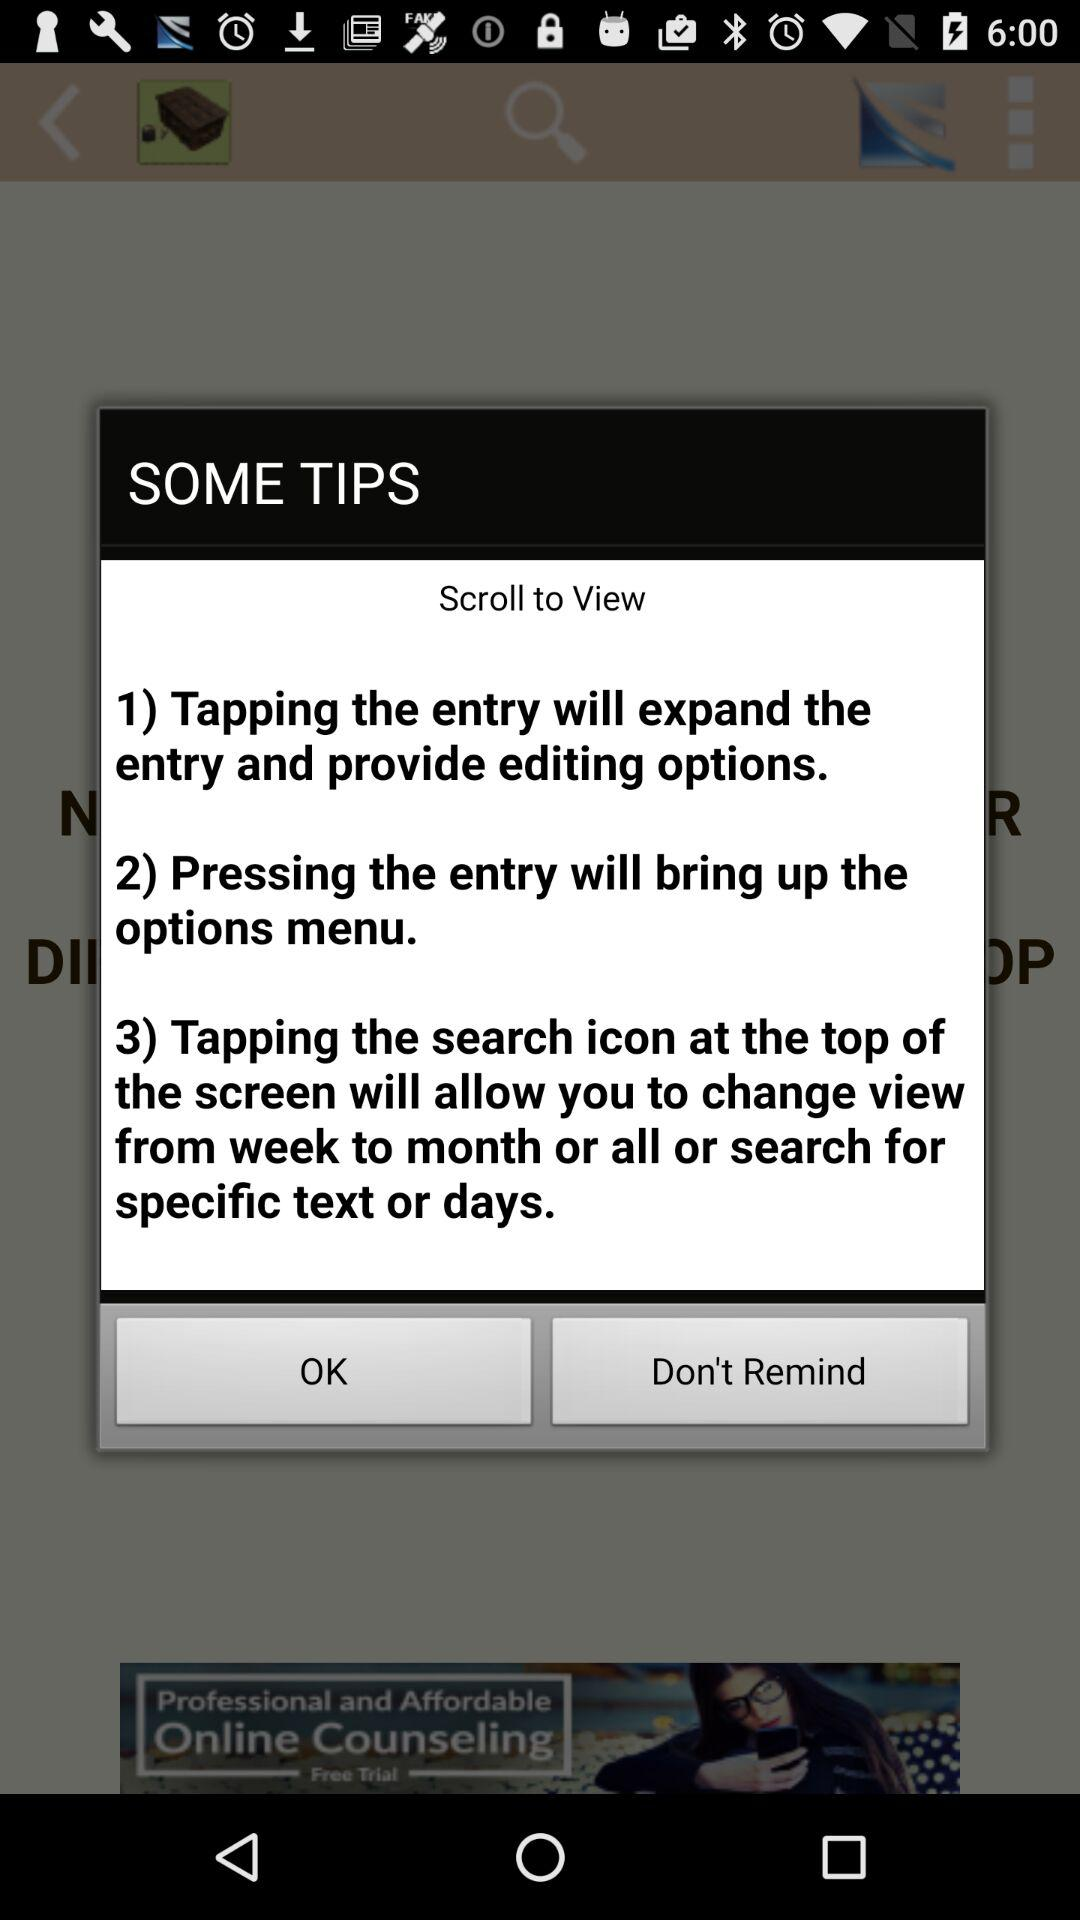How many tips are there in total?
Answer the question using a single word or phrase. 3 